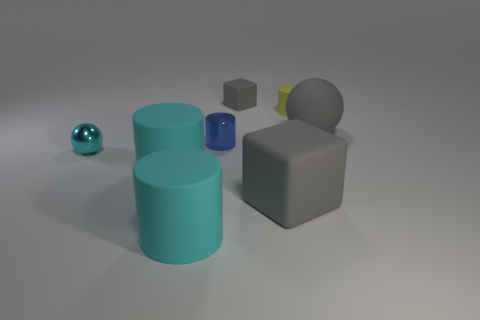Is the color of the large ball the same as the small matte cube?
Give a very brief answer. Yes. Is the object behind the tiny rubber cylinder made of the same material as the cube that is in front of the tiny blue metal thing?
Ensure brevity in your answer.  Yes. Is there a large brown thing?
Provide a succinct answer. No. There is a large gray object behind the big matte block; does it have the same shape as the shiny thing left of the tiny blue object?
Provide a short and direct response. Yes. Is there a tiny cylinder made of the same material as the small cyan object?
Give a very brief answer. Yes. Do the large gray object behind the small cyan shiny sphere and the small yellow thing have the same material?
Provide a succinct answer. Yes. Is the number of large gray matte things that are in front of the cyan metal sphere greater than the number of cylinders behind the tiny matte cube?
Provide a succinct answer. Yes. There is another rubber cylinder that is the same size as the blue cylinder; what color is it?
Keep it short and to the point. Yellow. Are there any small matte cubes that have the same color as the big rubber sphere?
Make the answer very short. Yes. There is a cube that is behind the matte ball; is it the same color as the rubber cube that is in front of the blue metal cylinder?
Provide a short and direct response. Yes. 